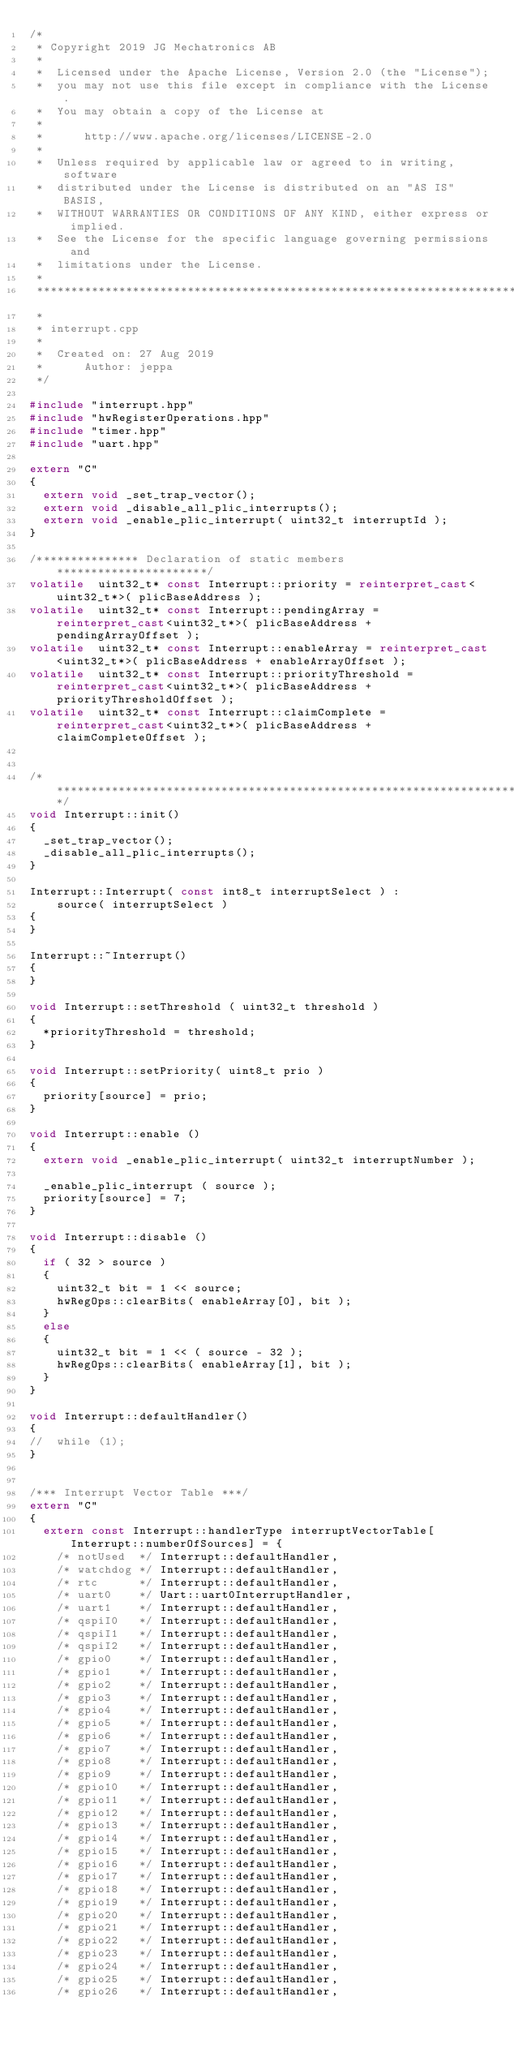<code> <loc_0><loc_0><loc_500><loc_500><_C++_>/*
 * Copyright 2019 JG Mechatronics AB
 *
 *  Licensed under the Apache License, Version 2.0 (the "License");
 *  you may not use this file except in compliance with the License.
 *  You may obtain a copy of the License at
 *
 *      http://www.apache.org/licenses/LICENSE-2.0
 *
 *  Unless required by applicable law or agreed to in writing, software
 *  distributed under the License is distributed on an "AS IS" BASIS,
 *  WITHOUT WARRANTIES OR CONDITIONS OF ANY KIND, either express or implied.
 *  See the License for the specific language governing permissions and
 *  limitations under the License.
 *
 *****************************************************************************
 *
 * interrupt.cpp
 *
 *  Created on: 27 Aug 2019
 *      Author: jeppa
 */

#include "interrupt.hpp"
#include "hwRegisterOperations.hpp"
#include "timer.hpp"
#include "uart.hpp"

extern "C"
{
	extern void _set_trap_vector();
	extern void _disable_all_plic_interrupts();
	extern void _enable_plic_interrupt( uint32_t interruptId );
}

/*************** Declaration of static members **********************/
volatile  uint32_t* const Interrupt::priority = reinterpret_cast<uint32_t*>( plicBaseAddress );
volatile  uint32_t* const Interrupt::pendingArray = reinterpret_cast<uint32_t*>( plicBaseAddress + pendingArrayOffset );
volatile  uint32_t* const Interrupt::enableArray = reinterpret_cast<uint32_t*>( plicBaseAddress + enableArrayOffset );
volatile  uint32_t* const Interrupt::priorityThreshold = reinterpret_cast<uint32_t*>( plicBaseAddress + priorityThresholdOffset );
volatile  uint32_t* const Interrupt::claimComplete = reinterpret_cast<uint32_t*>( plicBaseAddress + claimCompleteOffset );


/***********************************************************************/
void Interrupt::init()
{
	_set_trap_vector();
	_disable_all_plic_interrupts();
}

Interrupt::Interrupt( const int8_t interruptSelect ) :
    source( interruptSelect )
{
}

Interrupt::~Interrupt()
{
}

void Interrupt::setThreshold ( uint32_t threshold )
{
	*priorityThreshold = threshold;
}

void Interrupt::setPriority( uint8_t prio )
{
	priority[source] = prio;
}

void Interrupt::enable ()
{
	extern void _enable_plic_interrupt( uint32_t interruptNumber );

	_enable_plic_interrupt ( source );
	priority[source] = 7;
}

void Interrupt::disable ()
{
	if ( 32 > source )
	{
		uint32_t bit = 1 << source;
		hwRegOps::clearBits( enableArray[0], bit );
	}
	else
	{
		uint32_t bit = 1 << ( source - 32 );
		hwRegOps::clearBits( enableArray[1], bit );
	}
}

void Interrupt::defaultHandler()
{
//	while (1);
}


/*** Interrupt Vector Table ***/
extern "C"
{
	extern const Interrupt::handlerType interruptVectorTable[Interrupt::numberOfSources] = {
		/* notUsed  */ Interrupt::defaultHandler,
		/* watchdog */ Interrupt::defaultHandler,
		/* rtc      */ Interrupt::defaultHandler,
		/* uart0    */ Uart::uart0InterruptHandler,
		/* uart1    */ Interrupt::defaultHandler,
		/* qspiI0   */ Interrupt::defaultHandler,
		/* qspiI1   */ Interrupt::defaultHandler,
		/* qspiI2   */ Interrupt::defaultHandler,
		/* gpio0    */ Interrupt::defaultHandler,
		/* gpio1    */ Interrupt::defaultHandler,
		/* gpio2    */ Interrupt::defaultHandler,
		/* gpio3    */ Interrupt::defaultHandler,
		/* gpio4    */ Interrupt::defaultHandler,
		/* gpio5    */ Interrupt::defaultHandler,
		/* gpio6    */ Interrupt::defaultHandler,
		/* gpio7    */ Interrupt::defaultHandler,
		/* gpio8    */ Interrupt::defaultHandler,
		/* gpio9    */ Interrupt::defaultHandler,
		/* gpio10   */ Interrupt::defaultHandler,
		/* gpio11   */ Interrupt::defaultHandler,
		/* gpio12   */ Interrupt::defaultHandler,
		/* gpio13   */ Interrupt::defaultHandler,
		/* gpio14   */ Interrupt::defaultHandler,
		/* gpio15   */ Interrupt::defaultHandler,
		/* gpio16   */ Interrupt::defaultHandler,
		/* gpio17   */ Interrupt::defaultHandler,
		/* gpio18   */ Interrupt::defaultHandler,
		/* gpio19   */ Interrupt::defaultHandler,
		/* gpio20   */ Interrupt::defaultHandler,
		/* gpio21   */ Interrupt::defaultHandler,
		/* gpio22   */ Interrupt::defaultHandler,
		/* gpio23   */ Interrupt::defaultHandler,
		/* gpio24   */ Interrupt::defaultHandler,
		/* gpio25   */ Interrupt::defaultHandler,
		/* gpio26   */ Interrupt::defaultHandler,</code> 